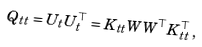<formula> <loc_0><loc_0><loc_500><loc_500>Q _ { t t } = U _ { t } U _ { t } ^ { \top } = K _ { t t } W W ^ { \top } K _ { t t } ^ { \top } \, ,</formula> 